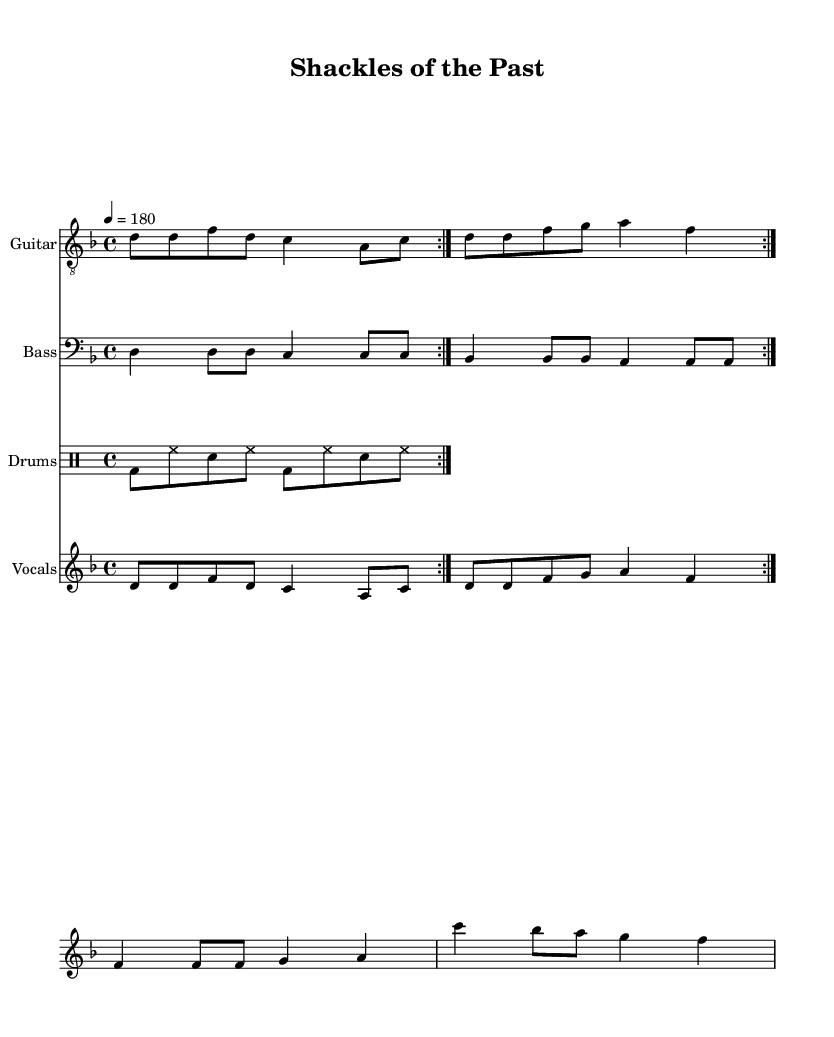What is the key signature of this music? The key signature shows 1 flat (B♭), indicating it is in D minor.
Answer: D minor What is the time signature of this piece? The time signature is found at the beginning of the sheet music, indicated by "4/4," meaning four beats per measure.
Answer: 4/4 What is the tempo marking for this piece? The tempo marking states "4 = 180," which indicates that there are 180 quarter note beats per minute.
Answer: 180 How many times is the verse repeated? The repeat instruction "volta 2" indicates that the verse section is played twice.
Answer: 2 Which instrument plays the main melody? The main melody is found in the "Vocals" staff, which contains the vocal line and lyrics.
Answer: Vocals What are the opening lyrics of the song? The opening lyrics can be found in the verse section, which starts with "Chains of the past."
Answer: Chains of the past What is the defining theme of the lyrics in this sheet music? The overall theme of the lyrics focuses on breaking free from a toxic relationship, as evident in lines detailing liberation and reclaiming one's soul.
Answer: Breaking free 